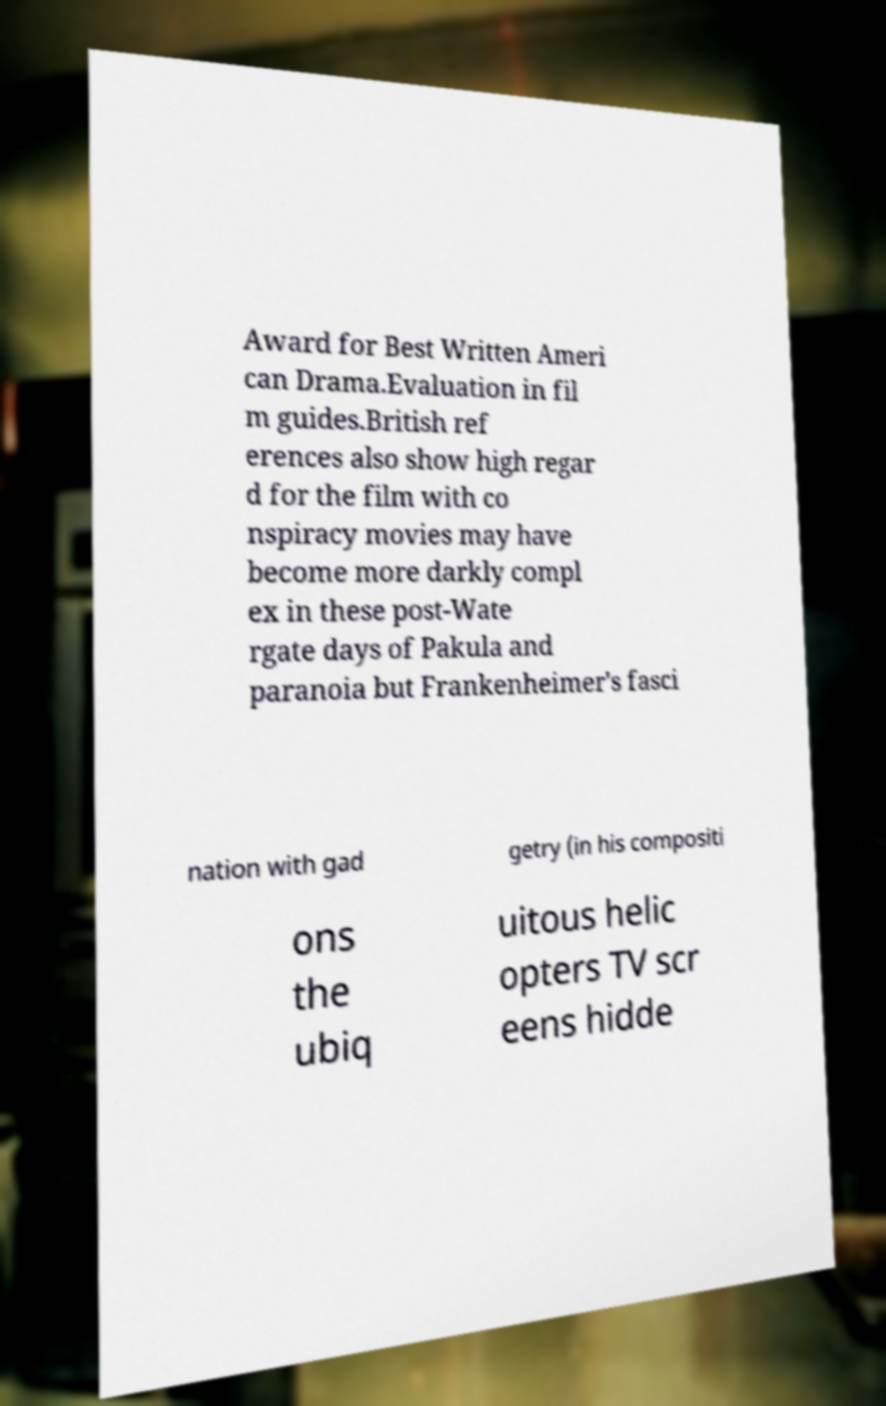For documentation purposes, I need the text within this image transcribed. Could you provide that? Award for Best Written Ameri can Drama.Evaluation in fil m guides.British ref erences also show high regar d for the film with co nspiracy movies may have become more darkly compl ex in these post-Wate rgate days of Pakula and paranoia but Frankenheimer's fasci nation with gad getry (in his compositi ons the ubiq uitous helic opters TV scr eens hidde 